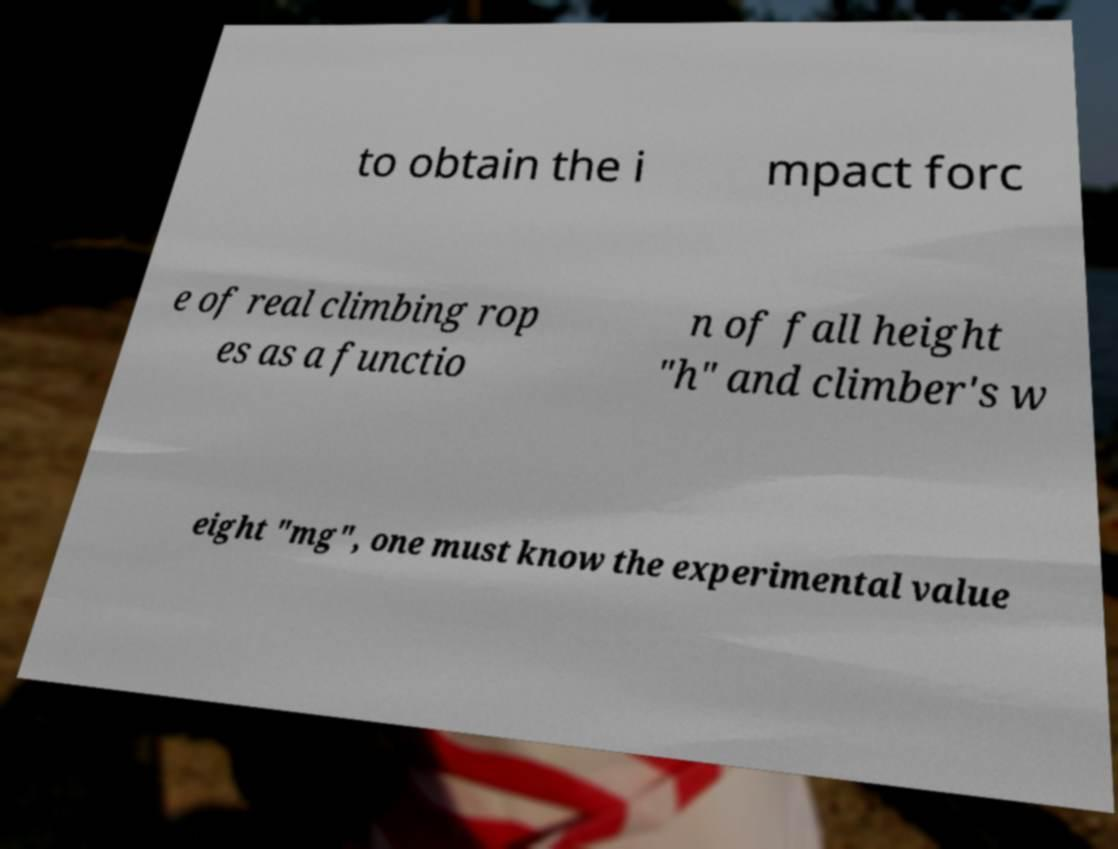Please identify and transcribe the text found in this image. to obtain the i mpact forc e of real climbing rop es as a functio n of fall height "h" and climber's w eight "mg", one must know the experimental value 